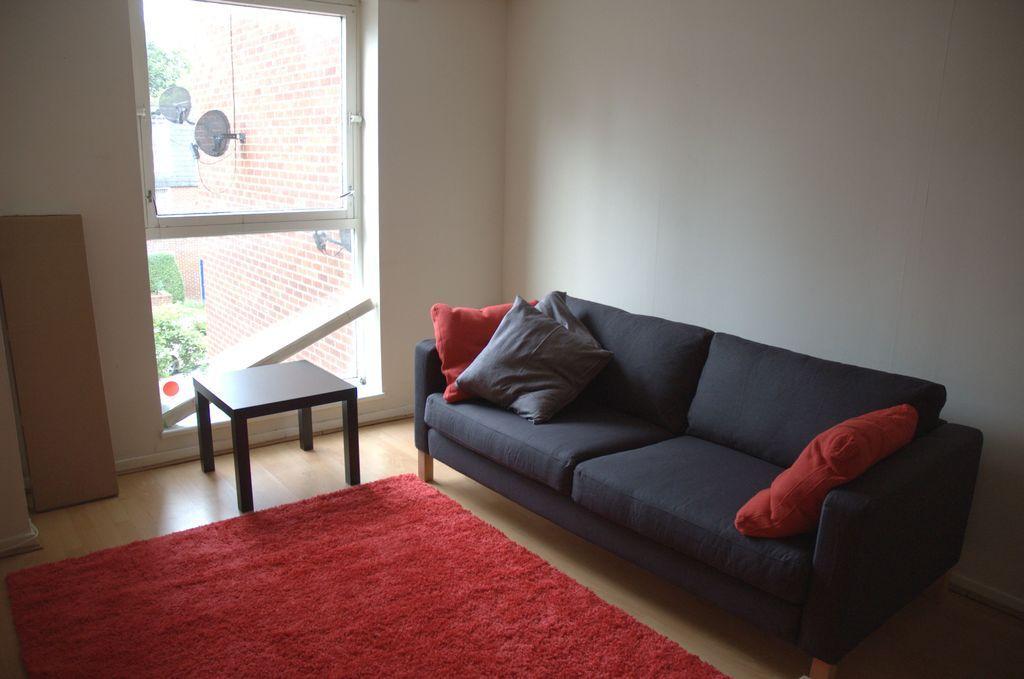Could you give a brief overview of what you see in this image? In this picture we can see inner view of room in which black coach is placed with three pillow two red and one grey. beside there is wooden small table and red rug placed on the ground. Behind we can see a white wall and glass door from which red brick wall and tree can be seen. 